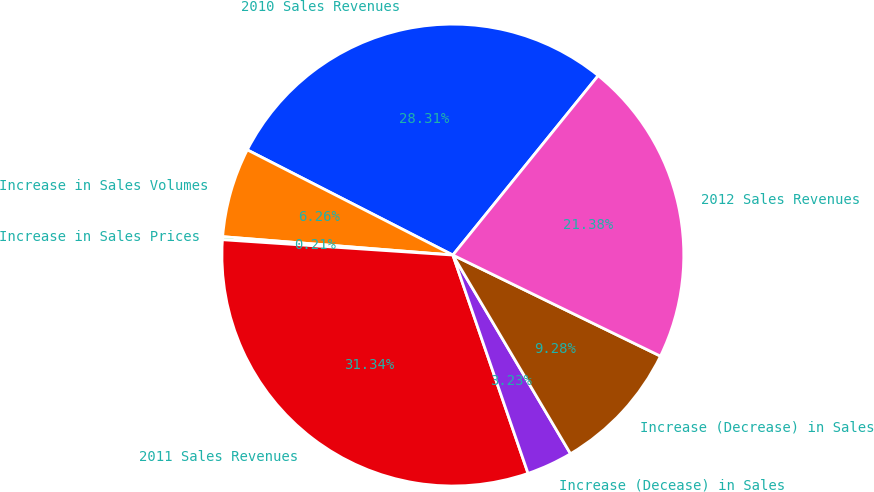Convert chart. <chart><loc_0><loc_0><loc_500><loc_500><pie_chart><fcel>2010 Sales Revenues<fcel>Increase in Sales Volumes<fcel>Increase in Sales Prices<fcel>2011 Sales Revenues<fcel>Increase (Decease) in Sales<fcel>Increase (Decrease) in Sales<fcel>2012 Sales Revenues<nl><fcel>28.31%<fcel>6.26%<fcel>0.21%<fcel>31.34%<fcel>3.23%<fcel>9.28%<fcel>21.38%<nl></chart> 